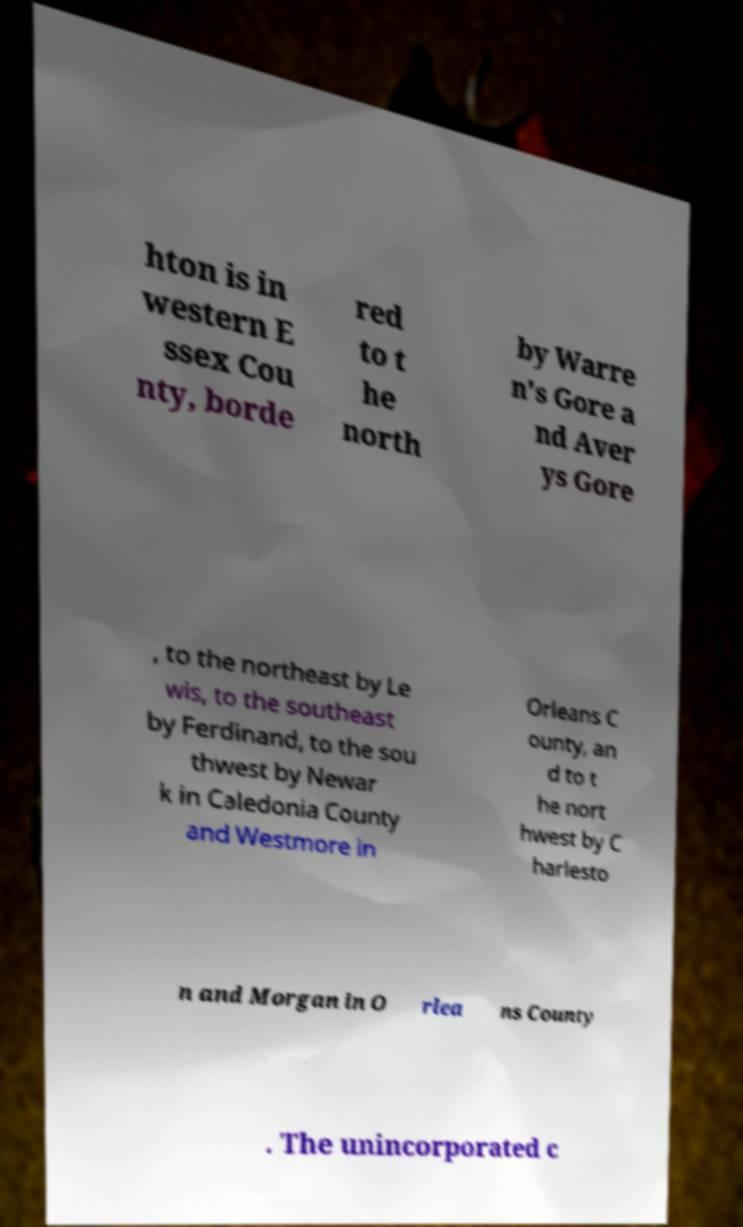For documentation purposes, I need the text within this image transcribed. Could you provide that? hton is in western E ssex Cou nty, borde red to t he north by Warre n's Gore a nd Aver ys Gore , to the northeast by Le wis, to the southeast by Ferdinand, to the sou thwest by Newar k in Caledonia County and Westmore in Orleans C ounty, an d to t he nort hwest by C harlesto n and Morgan in O rlea ns County . The unincorporated c 